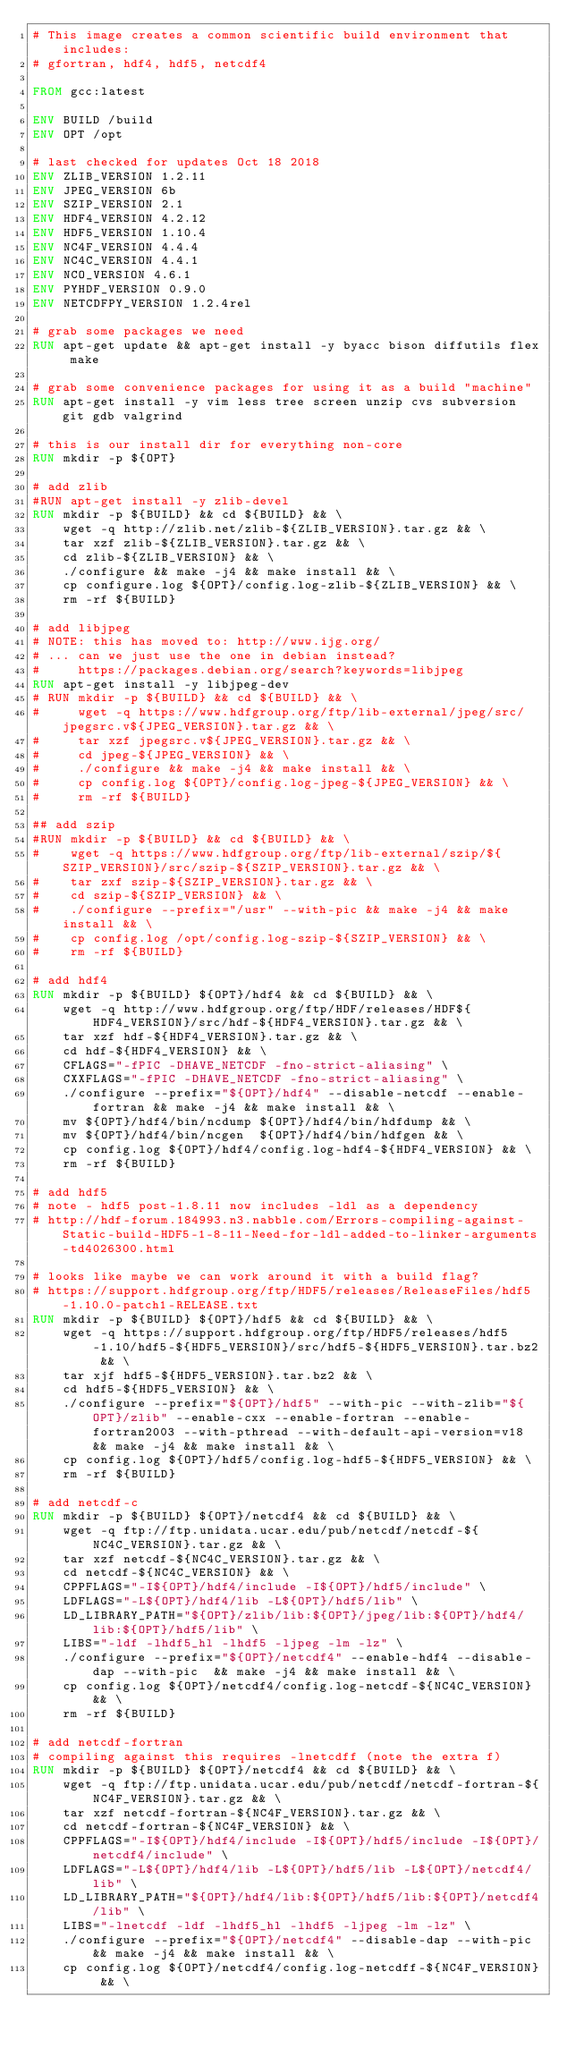Convert code to text. <code><loc_0><loc_0><loc_500><loc_500><_Dockerfile_># This image creates a common scientific build environment that includes:
# gfortran, hdf4, hdf5, netcdf4

FROM gcc:latest

ENV BUILD /build
ENV OPT /opt

# last checked for updates Oct 18 2018
ENV ZLIB_VERSION 1.2.11
ENV JPEG_VERSION 6b
ENV SZIP_VERSION 2.1
ENV HDF4_VERSION 4.2.12
ENV HDF5_VERSION 1.10.4
ENV NC4F_VERSION 4.4.4
ENV NC4C_VERSION 4.4.1
ENV NCO_VERSION 4.6.1
ENV PYHDF_VERSION 0.9.0
ENV NETCDFPY_VERSION 1.2.4rel

# grab some packages we need
RUN apt-get update && apt-get install -y byacc bison diffutils flex make

# grab some convenience packages for using it as a build "machine"
RUN apt-get install -y vim less tree screen unzip cvs subversion git gdb valgrind

# this is our install dir for everything non-core
RUN mkdir -p ${OPT}

# add zlib
#RUN apt-get install -y zlib-devel
RUN mkdir -p ${BUILD} && cd ${BUILD} && \
    wget -q http://zlib.net/zlib-${ZLIB_VERSION}.tar.gz && \
    tar xzf zlib-${ZLIB_VERSION}.tar.gz && \
    cd zlib-${ZLIB_VERSION} && \
    ./configure && make -j4 && make install && \
    cp configure.log ${OPT}/config.log-zlib-${ZLIB_VERSION} && \
    rm -rf ${BUILD}

# add libjpeg
# NOTE: this has moved to: http://www.ijg.org/
# ... can we just use the one in debian instead?
#     https://packages.debian.org/search?keywords=libjpeg
RUN apt-get install -y libjpeg-dev
# RUN mkdir -p ${BUILD} && cd ${BUILD} && \
#     wget -q https://www.hdfgroup.org/ftp/lib-external/jpeg/src/jpegsrc.v${JPEG_VERSION}.tar.gz && \
#     tar xzf jpegsrc.v${JPEG_VERSION}.tar.gz && \
#     cd jpeg-${JPEG_VERSION} && \
#     ./configure && make -j4 && make install && \
#     cp config.log ${OPT}/config.log-jpeg-${JPEG_VERSION} && \
#     rm -rf ${BUILD}

## add szip
#RUN mkdir -p ${BUILD} && cd ${BUILD} && \
#    wget -q https://www.hdfgroup.org/ftp/lib-external/szip/${SZIP_VERSION}/src/szip-${SZIP_VERSION}.tar.gz && \
#    tar zxf szip-${SZIP_VERSION}.tar.gz && \
#    cd szip-${SZIP_VERSION} && \
#    ./configure --prefix="/usr" --with-pic && make -j4 && make install && \
#    cp config.log /opt/config.log-szip-${SZIP_VERSION} && \
#    rm -rf ${BUILD}

# add hdf4
RUN mkdir -p ${BUILD} ${OPT}/hdf4 && cd ${BUILD} && \
    wget -q http://www.hdfgroup.org/ftp/HDF/releases/HDF${HDF4_VERSION}/src/hdf-${HDF4_VERSION}.tar.gz && \
    tar xzf hdf-${HDF4_VERSION}.tar.gz && \
    cd hdf-${HDF4_VERSION} && \
    CFLAGS="-fPIC -DHAVE_NETCDF -fno-strict-aliasing" \
    CXXFLAGS="-fPIC -DHAVE_NETCDF -fno-strict-aliasing" \
    ./configure --prefix="${OPT}/hdf4" --disable-netcdf --enable-fortran && make -j4 && make install && \
    mv ${OPT}/hdf4/bin/ncdump ${OPT}/hdf4/bin/hdfdump && \
    mv ${OPT}/hdf4/bin/ncgen  ${OPT}/hdf4/bin/hdfgen && \
    cp config.log ${OPT}/hdf4/config.log-hdf4-${HDF4_VERSION} && \
    rm -rf ${BUILD}

# add hdf5
# note - hdf5 post-1.8.11 now includes -ldl as a dependency
# http://hdf-forum.184993.n3.nabble.com/Errors-compiling-against-Static-build-HDF5-1-8-11-Need-for-ldl-added-to-linker-arguments-td4026300.html

# looks like maybe we can work around it with a build flag?
# https://support.hdfgroup.org/ftp/HDF5/releases/ReleaseFiles/hdf5-1.10.0-patch1-RELEASE.txt
RUN mkdir -p ${BUILD} ${OPT}/hdf5 && cd ${BUILD} && \
    wget -q https://support.hdfgroup.org/ftp/HDF5/releases/hdf5-1.10/hdf5-${HDF5_VERSION}/src/hdf5-${HDF5_VERSION}.tar.bz2 && \
    tar xjf hdf5-${HDF5_VERSION}.tar.bz2 && \
    cd hdf5-${HDF5_VERSION} && \
    ./configure --prefix="${OPT}/hdf5" --with-pic --with-zlib="${OPT}/zlib" --enable-cxx --enable-fortran --enable-fortran2003 --with-pthread --with-default-api-version=v18 && make -j4 && make install && \
    cp config.log ${OPT}/hdf5/config.log-hdf5-${HDF5_VERSION} && \
    rm -rf ${BUILD}

# add netcdf-c
RUN mkdir -p ${BUILD} ${OPT}/netcdf4 && cd ${BUILD} && \
    wget -q ftp://ftp.unidata.ucar.edu/pub/netcdf/netcdf-${NC4C_VERSION}.tar.gz && \
    tar xzf netcdf-${NC4C_VERSION}.tar.gz && \
    cd netcdf-${NC4C_VERSION} && \
    CPPFLAGS="-I${OPT}/hdf4/include -I${OPT}/hdf5/include" \
    LDFLAGS="-L${OPT}/hdf4/lib -L${OPT}/hdf5/lib" \
    LD_LIBRARY_PATH="${OPT}/zlib/lib:${OPT}/jpeg/lib:${OPT}/hdf4/lib:${OPT}/hdf5/lib" \
    LIBS="-ldf -lhdf5_hl -lhdf5 -ljpeg -lm -lz" \
    ./configure --prefix="${OPT}/netcdf4" --enable-hdf4 --disable-dap --with-pic  && make -j4 && make install && \
    cp config.log ${OPT}/netcdf4/config.log-netcdf-${NC4C_VERSION} && \
    rm -rf ${BUILD}

# add netcdf-fortran
# compiling against this requires -lnetcdff (note the extra f)
RUN mkdir -p ${BUILD} ${OPT}/netcdf4 && cd ${BUILD} && \
    wget -q ftp://ftp.unidata.ucar.edu/pub/netcdf/netcdf-fortran-${NC4F_VERSION}.tar.gz && \
    tar xzf netcdf-fortran-${NC4F_VERSION}.tar.gz && \
    cd netcdf-fortran-${NC4F_VERSION} && \
    CPPFLAGS="-I${OPT}/hdf4/include -I${OPT}/hdf5/include -I${OPT}/netcdf4/include" \
    LDFLAGS="-L${OPT}/hdf4/lib -L${OPT}/hdf5/lib -L${OPT}/netcdf4/lib" \
    LD_LIBRARY_PATH="${OPT}/hdf4/lib:${OPT}/hdf5/lib:${OPT}/netcdf4/lib" \
    LIBS="-lnetcdf -ldf -lhdf5_hl -lhdf5 -ljpeg -lm -lz" \
    ./configure --prefix="${OPT}/netcdf4" --disable-dap --with-pic && make -j4 && make install && \
    cp config.log ${OPT}/netcdf4/config.log-netcdff-${NC4F_VERSION} && \</code> 